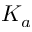Convert formula to latex. <formula><loc_0><loc_0><loc_500><loc_500>K _ { a }</formula> 